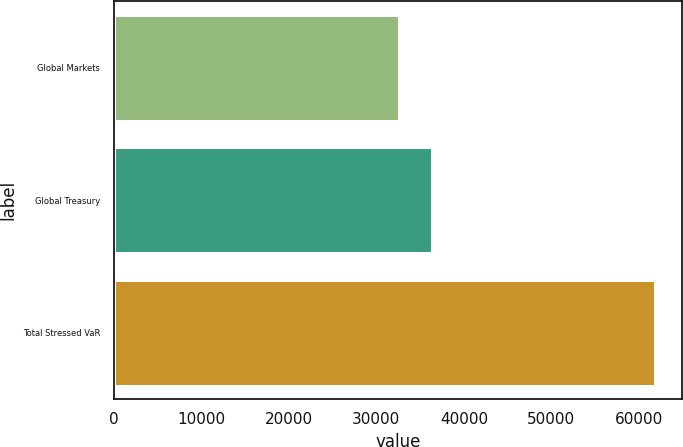Convert chart. <chart><loc_0><loc_0><loc_500><loc_500><bar_chart><fcel>Global Markets<fcel>Global Treasury<fcel>Total Stressed VaR<nl><fcel>32639<fcel>36344<fcel>61874<nl></chart> 